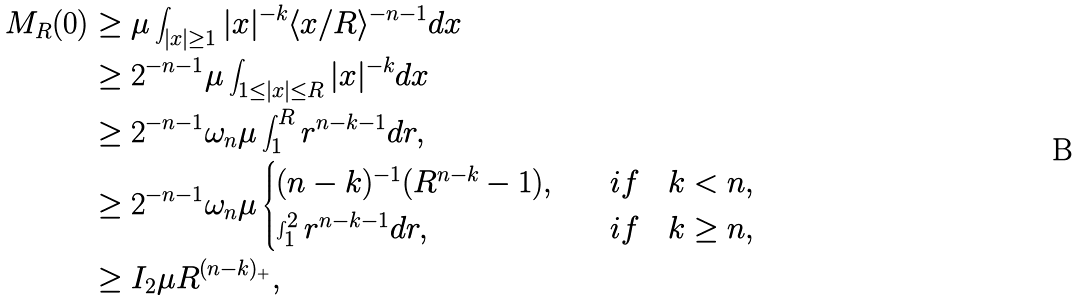Convert formula to latex. <formula><loc_0><loc_0><loc_500><loc_500>M _ { R } ( 0 ) & \geq \mu \int _ { | x | \geq 1 } | x | ^ { - k } \langle x / R \rangle ^ { - n - 1 } d x \\ & \geq 2 ^ { - n - 1 } \mu \int _ { 1 \leq | x | \leq R } | x | ^ { - k } d x \\ & \geq 2 ^ { - n - 1 } \omega _ { n } \mu \int _ { 1 } ^ { R } r ^ { n - k - 1 } d r , \\ & \geq 2 ^ { - n - 1 } \omega _ { n } \mu \begin{cases} ( n - k ) ^ { - 1 } ( R ^ { n - k } - 1 ) , & \quad i f \quad k < n , \\ \int _ { 1 } ^ { 2 } r ^ { n - k - 1 } d r , & \quad i f \quad k \geq n , \end{cases} \\ & \geq I _ { 2 } \mu R ^ { ( n - k ) _ { + } } ,</formula> 